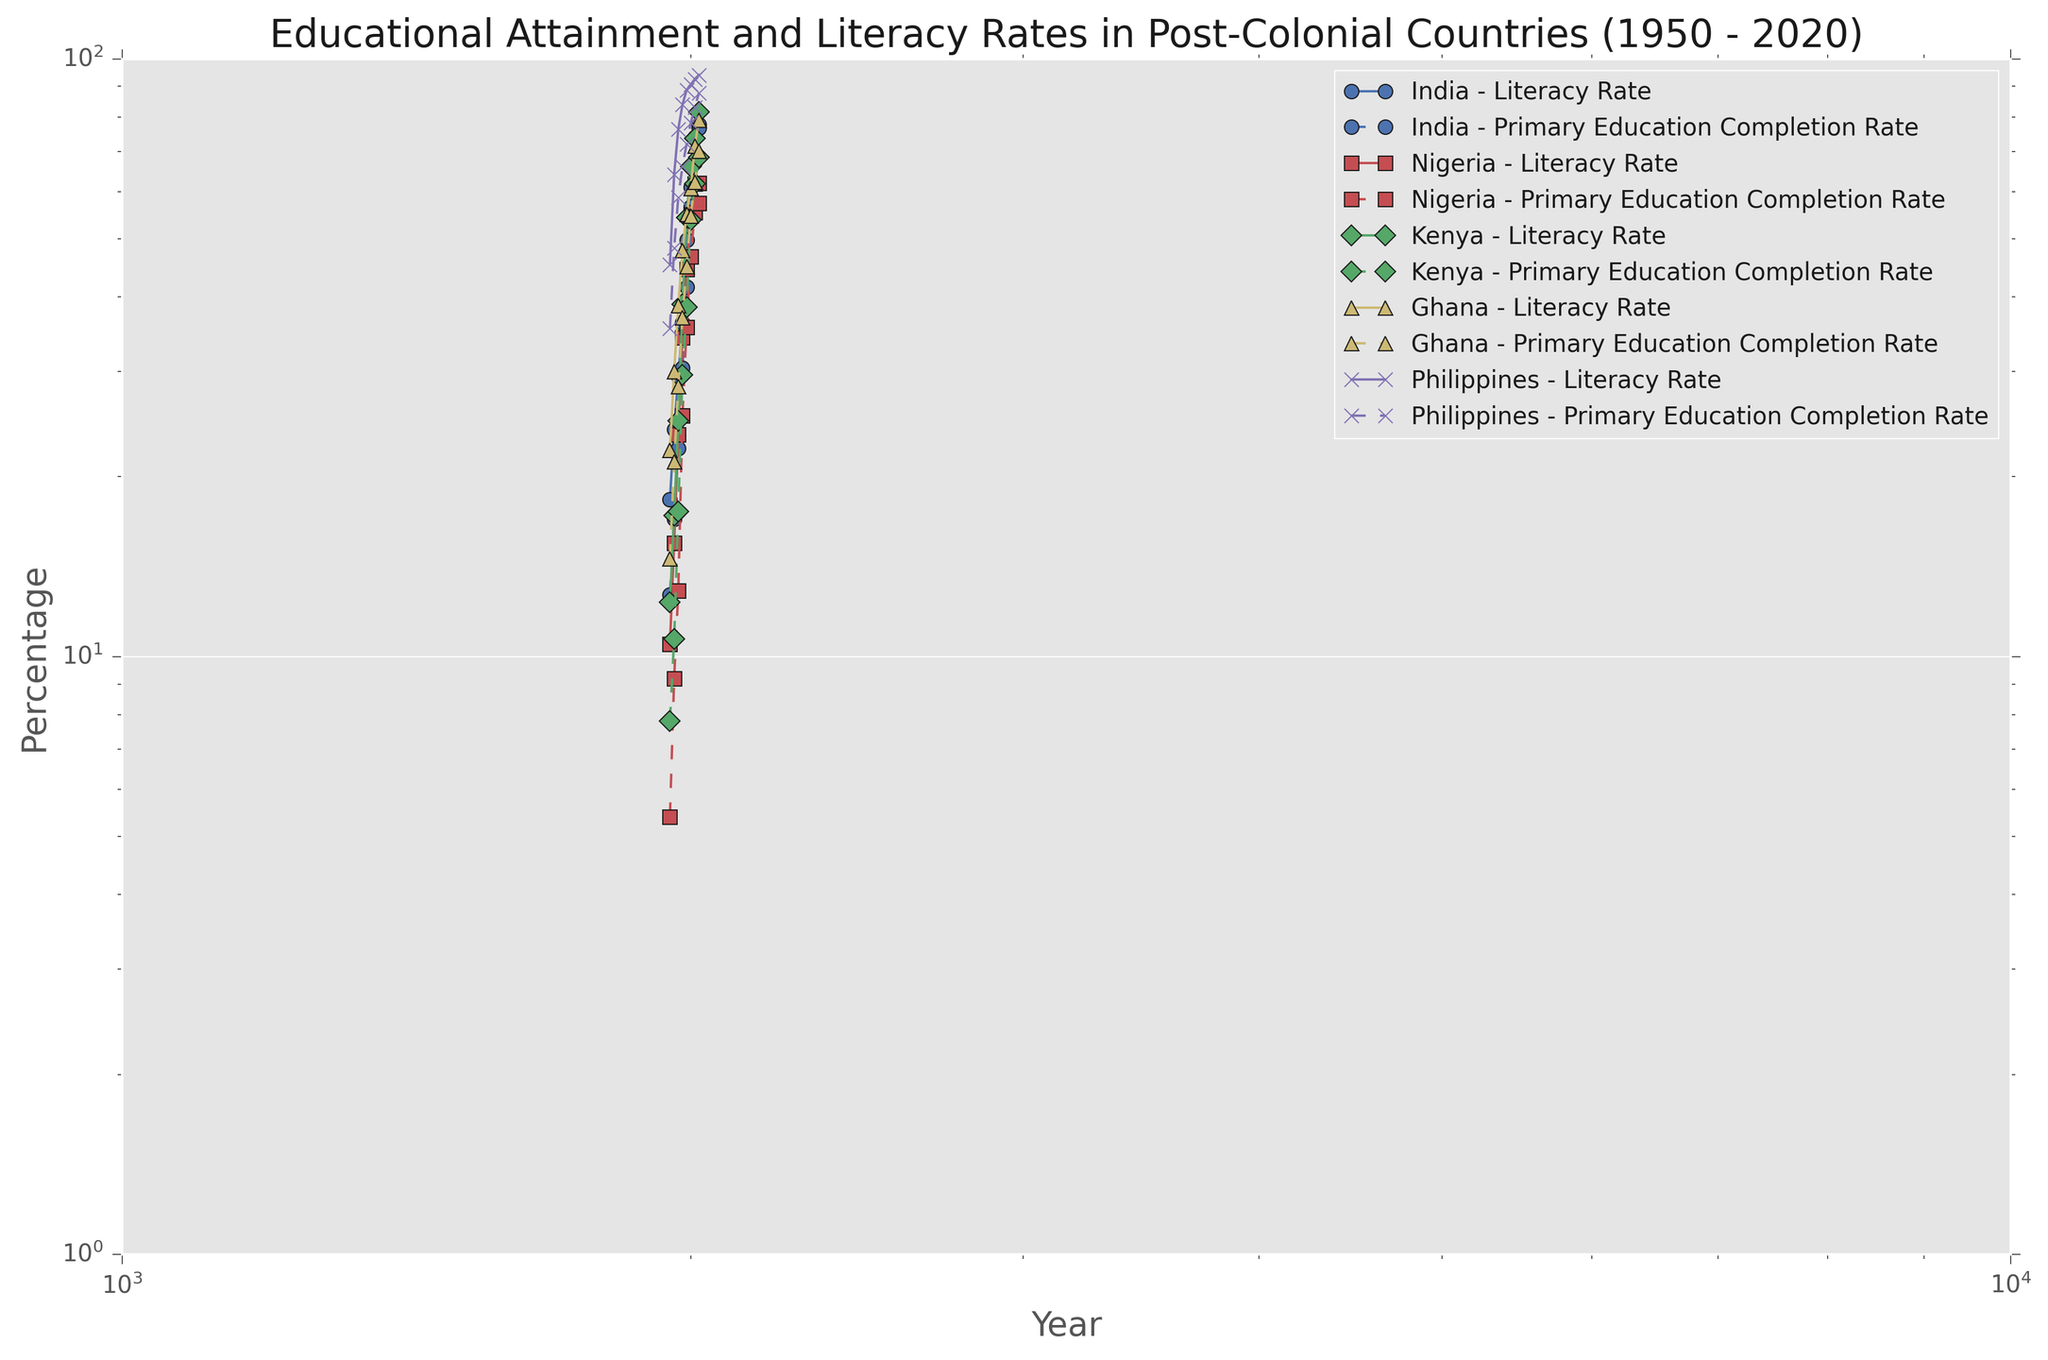When did India's literacy rate surpass 50%? By looking at the Literacy Rate line for India, identify the year when the rate first exceeds 50% on the logscale chart.
Answer: 1990 Which country had the lowest literacy rate in 1950? Compare the Literacy Rates for all countries in 1950. The country with the lowest rate will be discernible from the logscaled lines.
Answer: Nigeria By how much did Kenya's primary education completion rate increase between 1960 and 1970? Locate Kenya's Primary Education Completion Rate in 1960 and 1970 on the chart, then subtract the 1960 value from the 1970 value to find the increase.
Answer: 6.8% How does the literacy rate trend of the Philippines compare to that of Nigeria between 1950 and 2020? Compare the general direction and steepness of the Literacy Rate lines for the Philippines and Nigeria over time. The Philippines shows a steep and consistent rise, while Nigeria has a slower and more incremental rise.
Answer: Philippines' literacy rate increased more rapidly than Nigeria's What is the maximum difference between primary education completion rates in Ghana and India during the 1980s? Examine the lines for Primary Education Completion Rates of Ghana and India throughout the 1980s. Find the year with the highest difference by subtracting one country's rate from the other for each year in the 1980s.
Answer: 8.5% in 1980 Identify the country with the steepest increase in secondary education completion rate from 2000 to 2020. Evaluate the Secondary Education Completion Rate lines between 2000 and 2020. The country with the steepest slope indicates the steepest increase.
Answer: Kenya Which country had the highest tertiary education attainment rate in 2020? Compare the Tertiary Education Attainment Rates across all countries on the chart for the year 2020.
Answer: Philippines By how much did India's secondary education completion rate grow from 1950 to 2000? Locate India’s Secondary Education Completion Rate for the years 1950 and 2000 and subtract the 1950 value from the 2000 value to find the growth.
Answer: 29.5% Does Kenya ever surpass Ghana in literacy rate from 1950 to 2020? Over the entire span of 1950 to 2020, compare Kenya's Literacy Rate line with Ghana's. Look for any point where Kenya's rate exceeds Ghana's.
Answer: No 